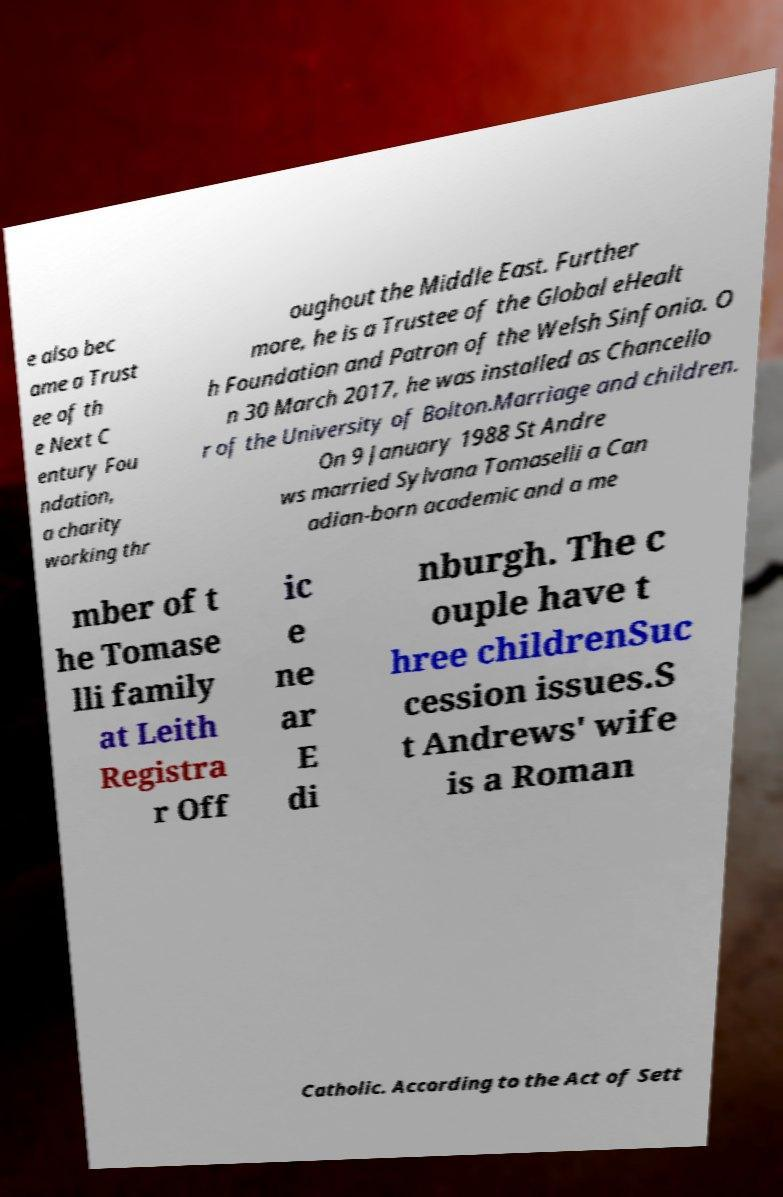Please identify and transcribe the text found in this image. e also bec ame a Trust ee of th e Next C entury Fou ndation, a charity working thr oughout the Middle East. Further more, he is a Trustee of the Global eHealt h Foundation and Patron of the Welsh Sinfonia. O n 30 March 2017, he was installed as Chancello r of the University of Bolton.Marriage and children. On 9 January 1988 St Andre ws married Sylvana Tomaselli a Can adian-born academic and a me mber of t he Tomase lli family at Leith Registra r Off ic e ne ar E di nburgh. The c ouple have t hree childrenSuc cession issues.S t Andrews' wife is a Roman Catholic. According to the Act of Sett 